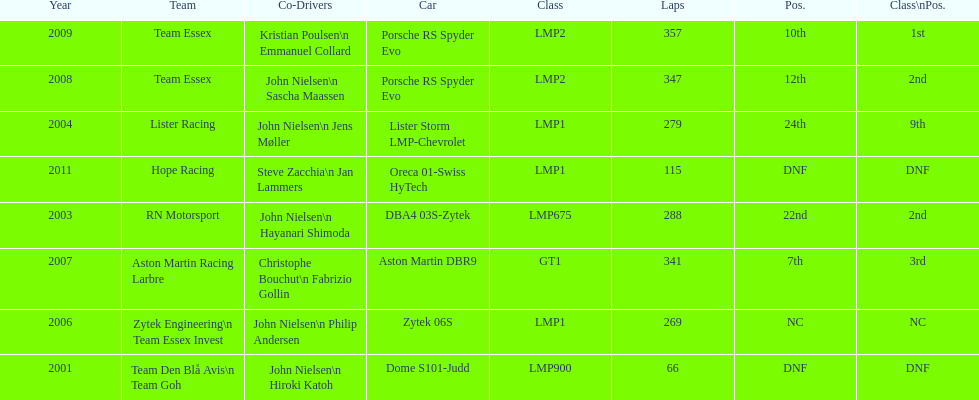How many times was the final position above 20? 2. 